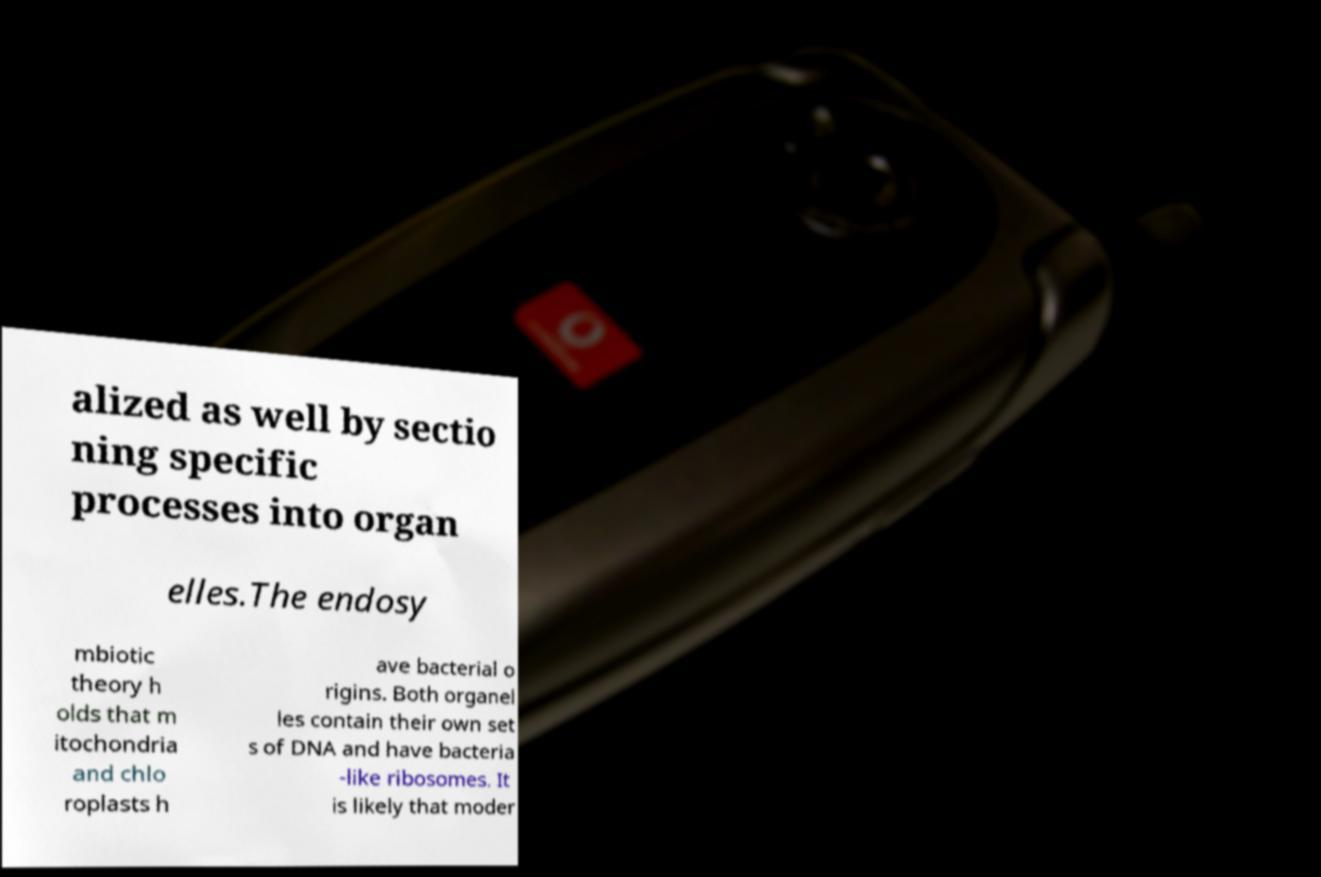There's text embedded in this image that I need extracted. Can you transcribe it verbatim? alized as well by sectio ning specific processes into organ elles.The endosy mbiotic theory h olds that m itochondria and chlo roplasts h ave bacterial o rigins. Both organel les contain their own set s of DNA and have bacteria -like ribosomes. It is likely that moder 